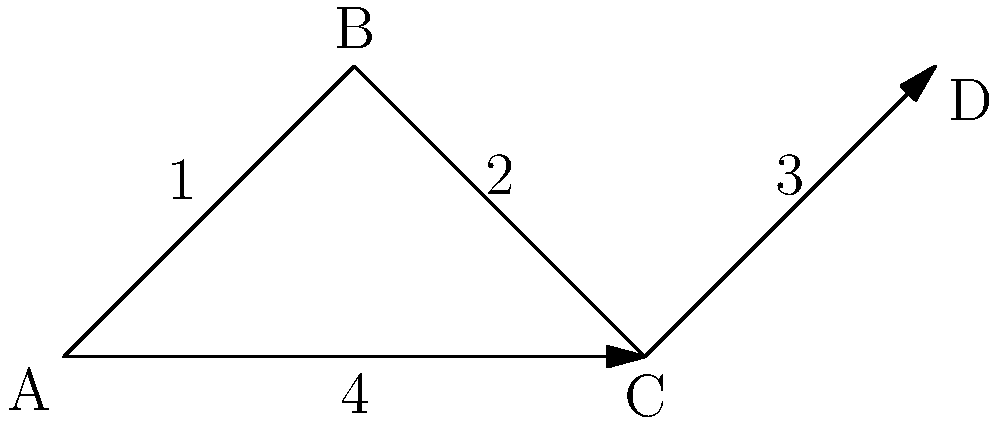In the genome assembly graph shown above, nodes represent genomic segments and edges represent connections between these segments. Edge labels indicate the number of supporting reads for each connection. Which path through this graph is most likely to represent a structural variation, such as an insertion or deletion, compared to the reference genome? To identify the path most likely representing a structural variation, we need to analyze the graph and consider the following steps:

1. Examine the graph structure:
   - The graph shows four nodes (A, B, C, D) connected by edges.
   - There are two possible paths from A to D: A-B-C-D and A-C-D.

2. Analyze edge support:
   - Path A-B-C-D has edge weights of 1, 2, and 3.
   - Path A-C-D has edge weights of 4 and 3.

3. Consider genomic implications:
   - Higher edge weights indicate stronger support from sequencing reads.
   - Lower edge weights may suggest novel connections or structural variations.

4. Compare the paths:
   - Path A-B-C-D includes a low-weight edge (1) between A and B.
   - Path A-C-D has consistently higher edge weights.

5. Interpret the results:
   - The low-weight edge in path A-B-C-D suggests a potential structural variation.
   - This could represent an insertion (of segment B) or a deletion (if B is absent in some samples).

6. Conclude:
   - Path A-B-C-D is more likely to represent a structural variation due to the presence of the low-weight edge, which may indicate a novel or less common genomic arrangement.
Answer: A-B-C-D 